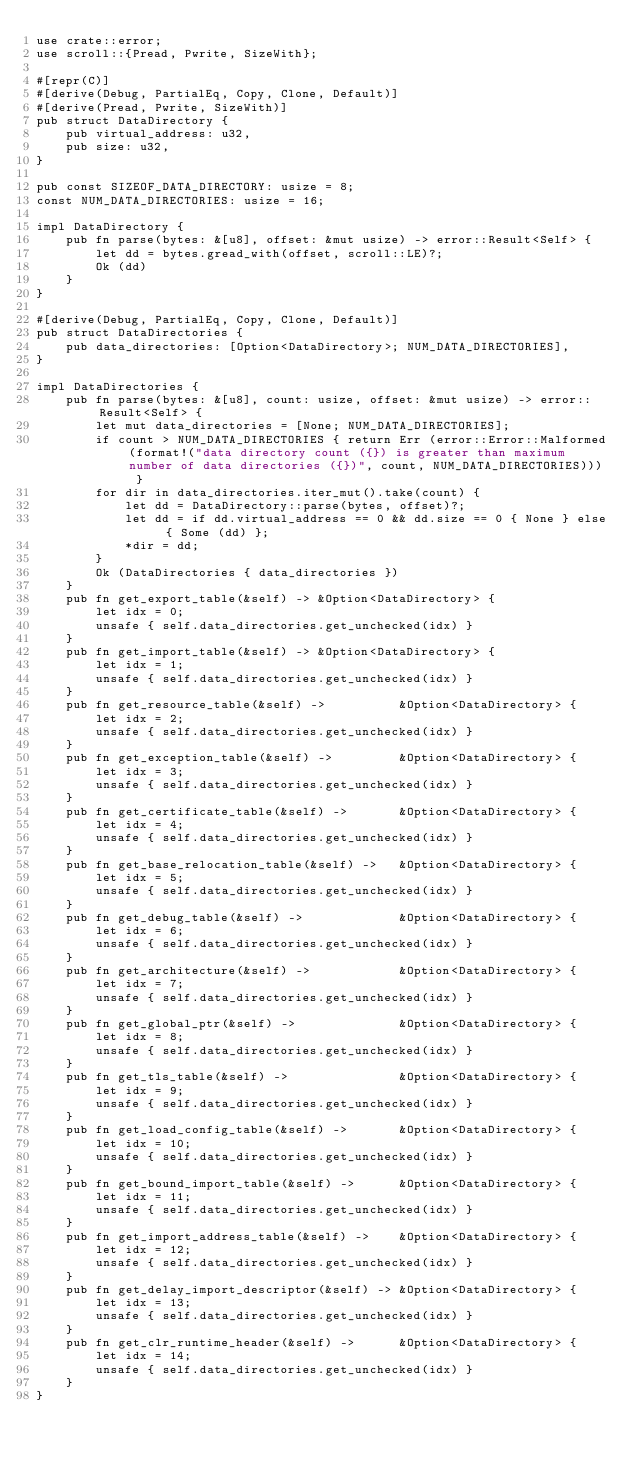<code> <loc_0><loc_0><loc_500><loc_500><_Rust_>use crate::error;
use scroll::{Pread, Pwrite, SizeWith};

#[repr(C)]
#[derive(Debug, PartialEq, Copy, Clone, Default)]
#[derive(Pread, Pwrite, SizeWith)]
pub struct DataDirectory {
    pub virtual_address: u32,
    pub size: u32,
}

pub const SIZEOF_DATA_DIRECTORY: usize = 8;
const NUM_DATA_DIRECTORIES: usize = 16;

impl DataDirectory {
    pub fn parse(bytes: &[u8], offset: &mut usize) -> error::Result<Self> {
        let dd = bytes.gread_with(offset, scroll::LE)?;
        Ok (dd)
    }
}

#[derive(Debug, PartialEq, Copy, Clone, Default)]
pub struct DataDirectories {
    pub data_directories: [Option<DataDirectory>; NUM_DATA_DIRECTORIES],
}

impl DataDirectories {
    pub fn parse(bytes: &[u8], count: usize, offset: &mut usize) -> error::Result<Self> {
        let mut data_directories = [None; NUM_DATA_DIRECTORIES];
        if count > NUM_DATA_DIRECTORIES { return Err (error::Error::Malformed(format!("data directory count ({}) is greater than maximum number of data directories ({})", count, NUM_DATA_DIRECTORIES))) }
        for dir in data_directories.iter_mut().take(count) {
            let dd = DataDirectory::parse(bytes, offset)?;
            let dd = if dd.virtual_address == 0 && dd.size == 0 { None } else { Some (dd) };
            *dir = dd;
        }
        Ok (DataDirectories { data_directories })
    }
    pub fn get_export_table(&self) -> &Option<DataDirectory> {
        let idx = 0;
        unsafe { self.data_directories.get_unchecked(idx) }
    }
    pub fn get_import_table(&self) -> &Option<DataDirectory> {
        let idx = 1;
        unsafe { self.data_directories.get_unchecked(idx) }
    }
    pub fn get_resource_table(&self) ->          &Option<DataDirectory> {
        let idx = 2;
        unsafe { self.data_directories.get_unchecked(idx) }
    }
    pub fn get_exception_table(&self) ->         &Option<DataDirectory> {
        let idx = 3;
        unsafe { self.data_directories.get_unchecked(idx) }
    }
    pub fn get_certificate_table(&self) ->       &Option<DataDirectory> {
        let idx = 4;
        unsafe { self.data_directories.get_unchecked(idx) }
    }
    pub fn get_base_relocation_table(&self) ->   &Option<DataDirectory> {
        let idx = 5;
        unsafe { self.data_directories.get_unchecked(idx) }
    }
    pub fn get_debug_table(&self) ->             &Option<DataDirectory> {
        let idx = 6;
        unsafe { self.data_directories.get_unchecked(idx) }
    }
    pub fn get_architecture(&self) ->            &Option<DataDirectory> {
        let idx = 7;
        unsafe { self.data_directories.get_unchecked(idx) }
    }
    pub fn get_global_ptr(&self) ->              &Option<DataDirectory> {
        let idx = 8;
        unsafe { self.data_directories.get_unchecked(idx) }
    }
    pub fn get_tls_table(&self) ->               &Option<DataDirectory> {
        let idx = 9;
        unsafe { self.data_directories.get_unchecked(idx) }
    }
    pub fn get_load_config_table(&self) ->       &Option<DataDirectory> {
        let idx = 10;
        unsafe { self.data_directories.get_unchecked(idx) }
    }
    pub fn get_bound_import_table(&self) ->      &Option<DataDirectory> {
        let idx = 11;
        unsafe { self.data_directories.get_unchecked(idx) }
    }
    pub fn get_import_address_table(&self) ->    &Option<DataDirectory> {
        let idx = 12;
        unsafe { self.data_directories.get_unchecked(idx) }
    }
    pub fn get_delay_import_descriptor(&self) -> &Option<DataDirectory> {
        let idx = 13;
        unsafe { self.data_directories.get_unchecked(idx) }
    }
    pub fn get_clr_runtime_header(&self) ->      &Option<DataDirectory> {
        let idx = 14;
        unsafe { self.data_directories.get_unchecked(idx) }
    }
}
</code> 